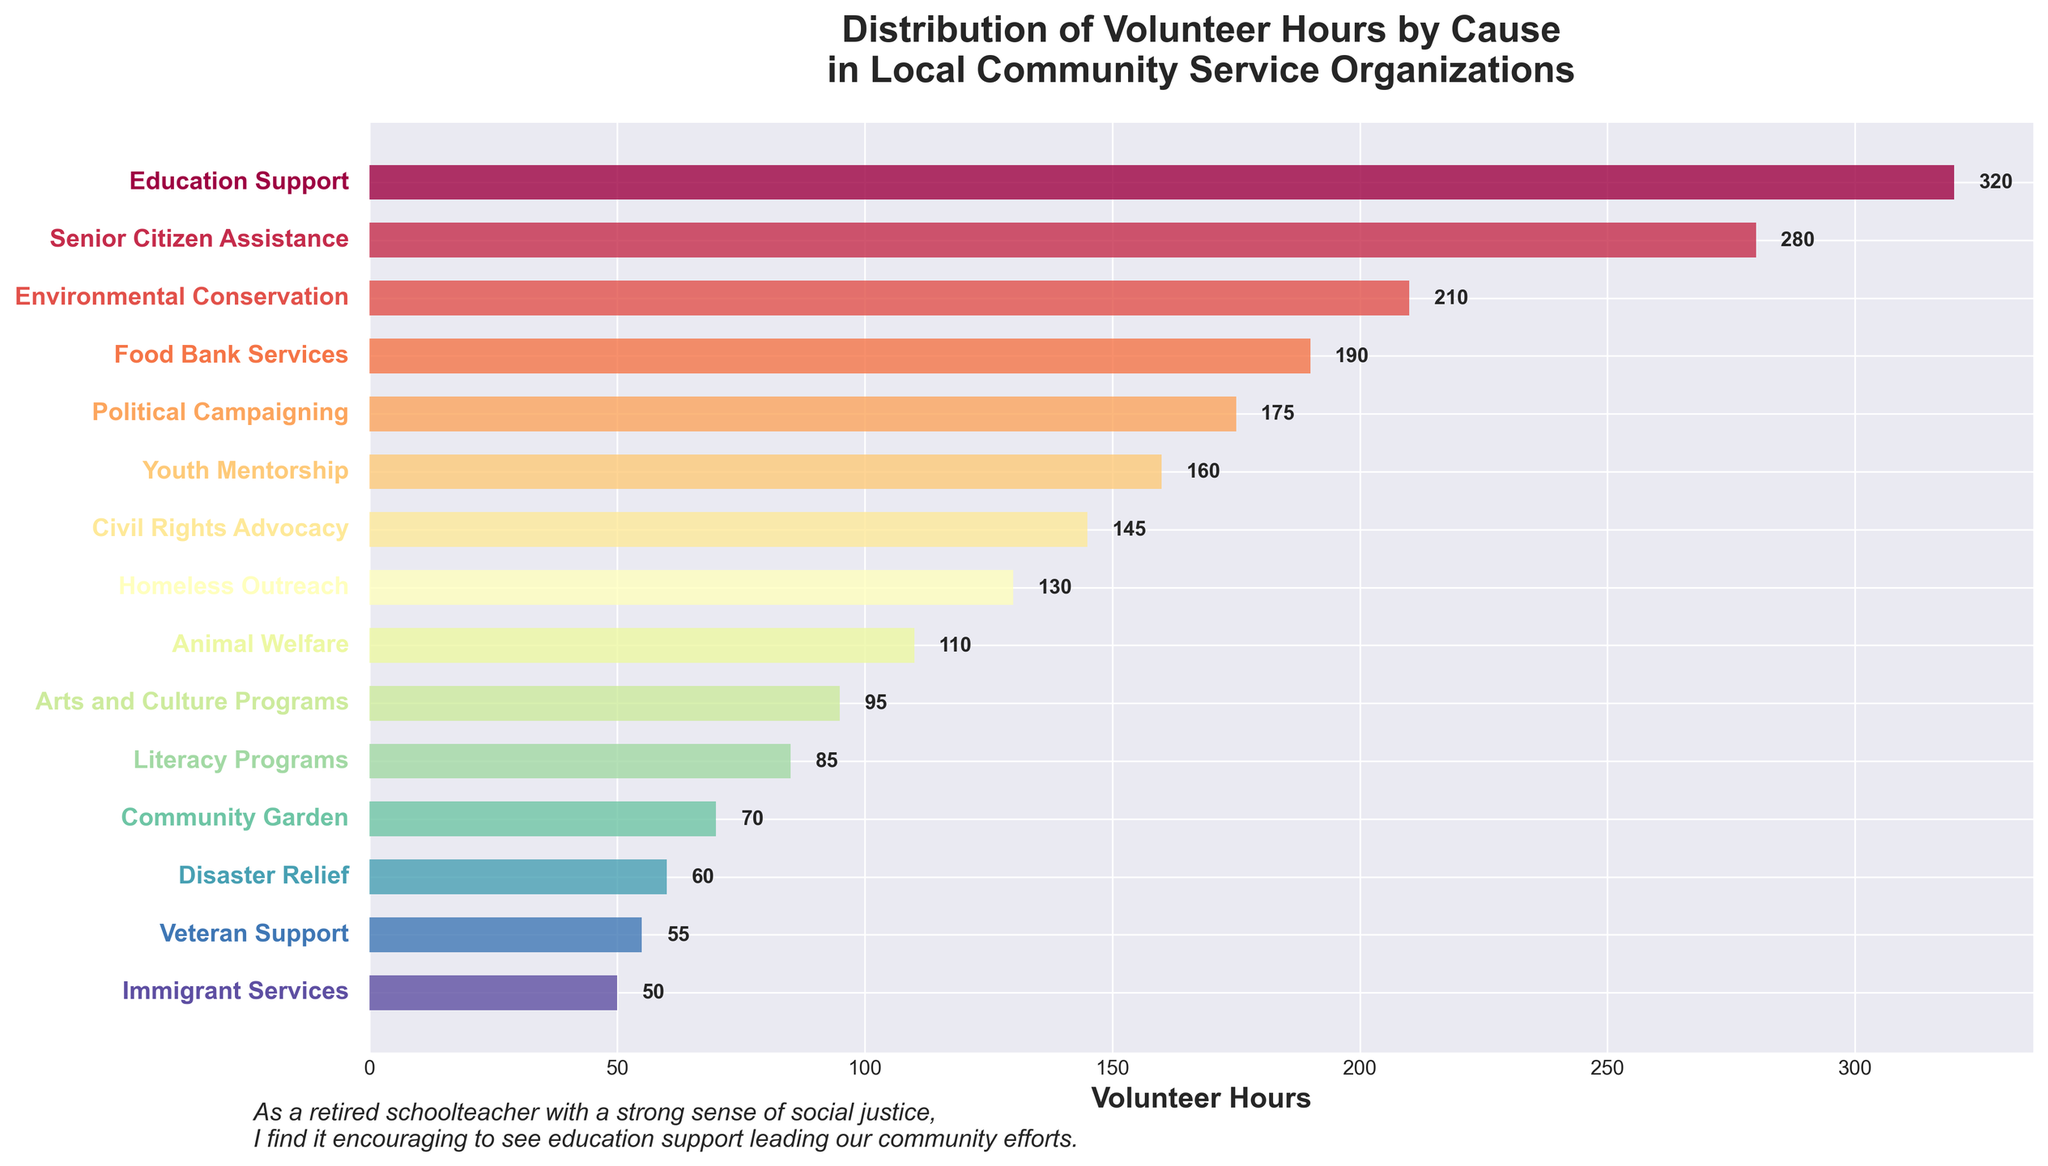Which cause has the highest number of volunteer hours? The bar representing Education Support is the longest, indicating the highest number of volunteer hours.
Answer: Education Support What is the difference in volunteer hours between Education Support and Senior Citizen Assistance? Education Support has 320 volunteer hours, and Senior Citizen Assistance has 280. The difference is 320 - 280.
Answer: 40 How many causes have fewer than 100 volunteer hours? Count bars representing causes with fewer than 100 hours: Arts and Culture Programs, Literacy Programs, Community Garden, Disaster Relief, Veteran Support, Immigrant Services.
Answer: 6 Which cause has the fewest volunteer hours? The shortest bar is for Immigrant Services.
Answer: Immigrant Services What is the total number of volunteer hours for the three least-supported causes? Immigrant Services (50), Veteran Support (55), and Disaster Relief (60). Add them up: 50 + 55 + 60.
Answer: 165 How much more volunteer hours does Environmental Conservation have compared to Animal Welfare? Environmental Conservation has 210 hours; Animal Welfare has 110. The difference is 210 - 110.
Answer: 100 Which causes have between 150 and 200 volunteer hours? Identify bars within this range: Food Bank Services (190), Political Campaigning (175), and Youth Mentorship (160).
Answer: Food Bank Services, Political Campaigning, Youth Mentorship Are there more volunteer hours for Civil Rights Advocacy or Homeless Outreach? Compare the lengths of the bars: Civil Rights Advocacy (145) and Homeless Outreach (130).
Answer: Civil Rights Advocacy What is the average number of volunteer hours for all the causes? Sum all volunteer hours (320 + 280 + 210 + 190 + 175 + 160 + 145 + 130 + 110 + 95 + 85 + 70 + 60 + 55 + 50 = 2135) and divide by the number of causes (15).
Answer: 142.33 Sort the causes in descending order based on volunteer hours. How many causes have more hours than Youth Mentorship? Identify bars greater than Youth Mentorship’s 160 hours: Education Support (320), Senior Citizen Assistance (280), Environmental Conservation (210), Food Bank Services (190), and Political Campaigning (175) — a total of five causes.
Answer: 5 